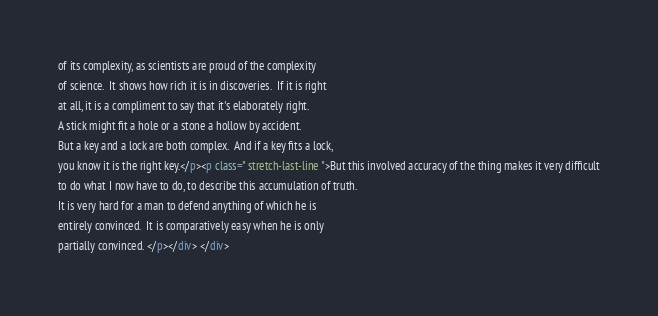Convert code to text. <code><loc_0><loc_0><loc_500><loc_500><_HTML_>of its complexity, as scientists are proud of the complexity
of science.  It shows how rich it is in discoveries.  If it is right
at all, it is a compliment to say that it's elaborately right.
A stick might fit a hole or a stone a hollow by accident.
But a key and a lock are both complex.  And if a key fits a lock,
you know it is the right key.</p><p class=" stretch-last-line ">But this involved accuracy of the thing makes it very difficult
to do what I now have to do, to describe this accumulation of truth.
It is very hard for a man to defend anything of which he is
entirely convinced.  It is comparatively easy when he is only
partially convinced. </p></div> </div></code> 